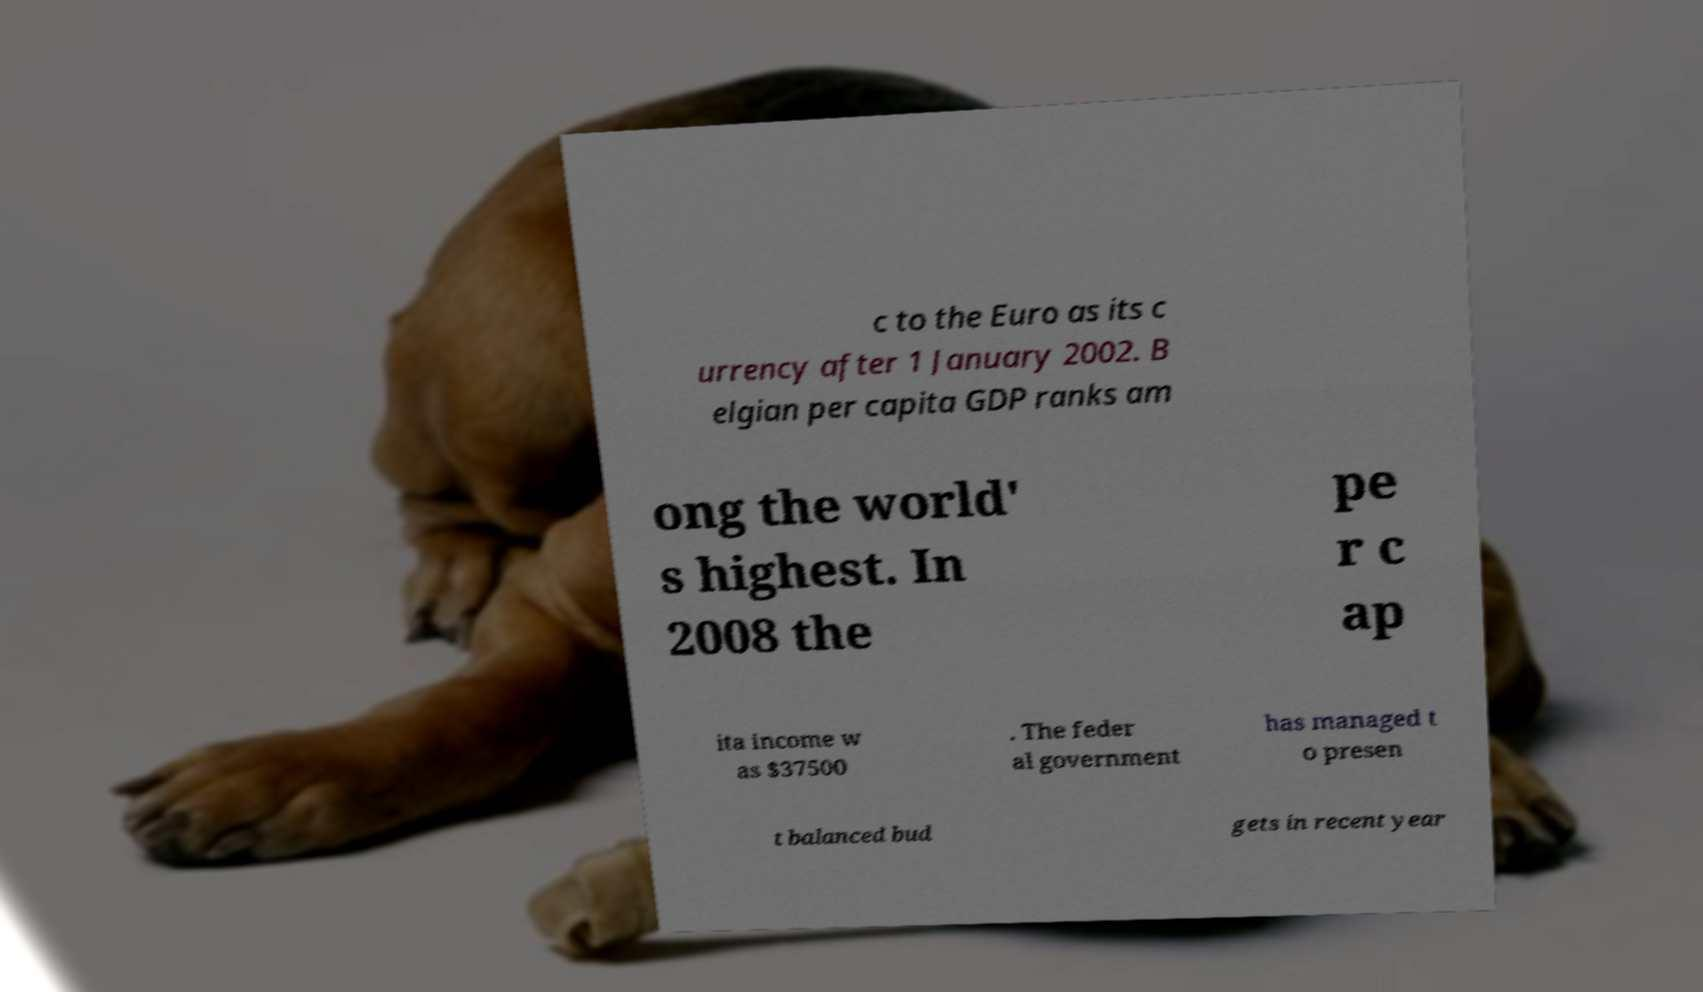There's text embedded in this image that I need extracted. Can you transcribe it verbatim? c to the Euro as its c urrency after 1 January 2002. B elgian per capita GDP ranks am ong the world' s highest. In 2008 the pe r c ap ita income w as $37500 . The feder al government has managed t o presen t balanced bud gets in recent year 